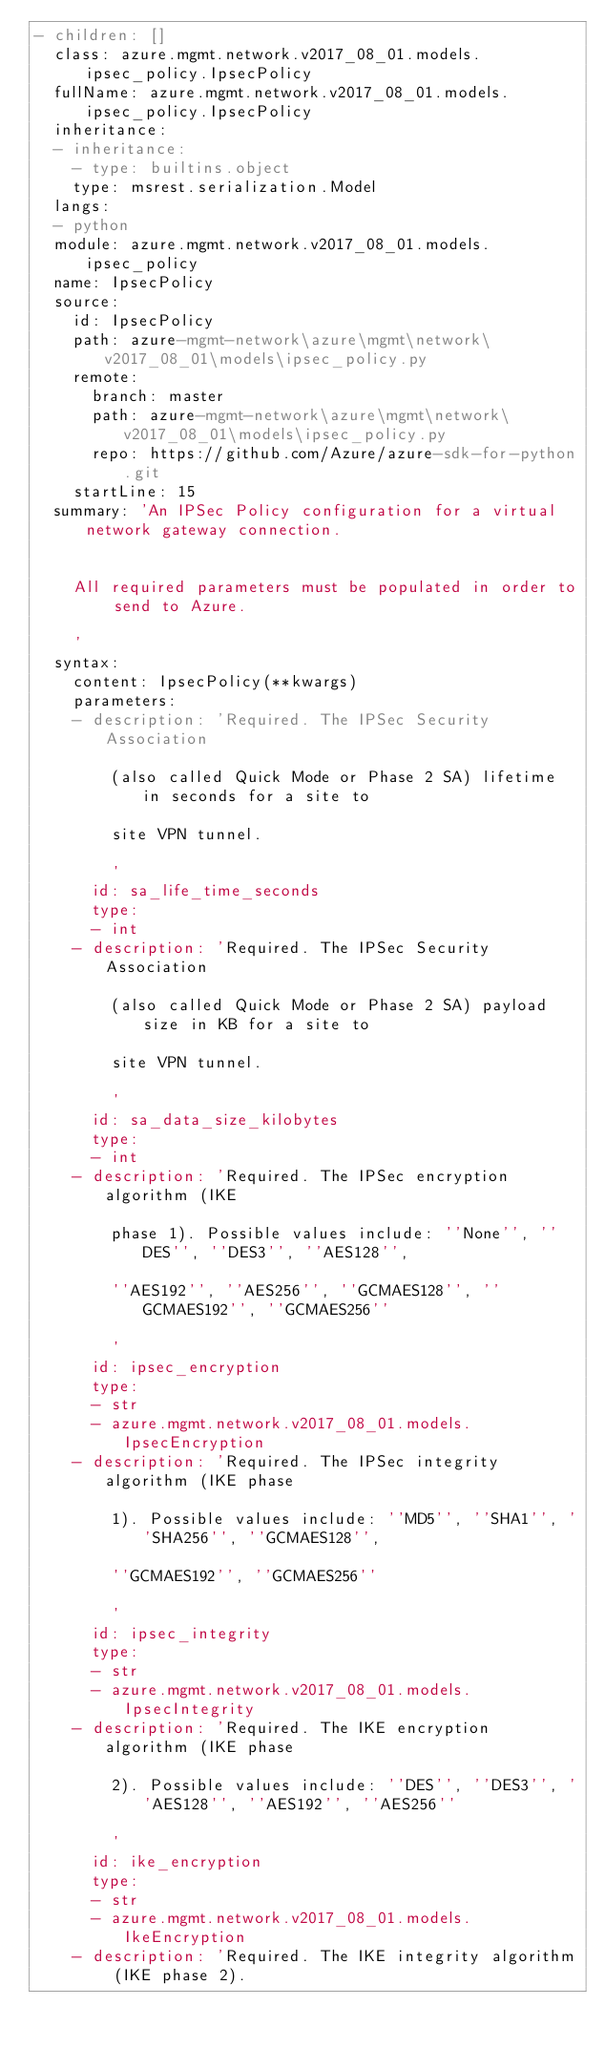Convert code to text. <code><loc_0><loc_0><loc_500><loc_500><_YAML_>- children: []
  class: azure.mgmt.network.v2017_08_01.models.ipsec_policy.IpsecPolicy
  fullName: azure.mgmt.network.v2017_08_01.models.ipsec_policy.IpsecPolicy
  inheritance:
  - inheritance:
    - type: builtins.object
    type: msrest.serialization.Model
  langs:
  - python
  module: azure.mgmt.network.v2017_08_01.models.ipsec_policy
  name: IpsecPolicy
  source:
    id: IpsecPolicy
    path: azure-mgmt-network\azure\mgmt\network\v2017_08_01\models\ipsec_policy.py
    remote:
      branch: master
      path: azure-mgmt-network\azure\mgmt\network\v2017_08_01\models\ipsec_policy.py
      repo: https://github.com/Azure/azure-sdk-for-python.git
    startLine: 15
  summary: 'An IPSec Policy configuration for a virtual network gateway connection.


    All required parameters must be populated in order to send to Azure.

    '
  syntax:
    content: IpsecPolicy(**kwargs)
    parameters:
    - description: 'Required. The IPSec Security Association

        (also called Quick Mode or Phase 2 SA) lifetime in seconds for a site to

        site VPN tunnel.

        '
      id: sa_life_time_seconds
      type:
      - int
    - description: 'Required. The IPSec Security Association

        (also called Quick Mode or Phase 2 SA) payload size in KB for a site to

        site VPN tunnel.

        '
      id: sa_data_size_kilobytes
      type:
      - int
    - description: 'Required. The IPSec encryption algorithm (IKE

        phase 1). Possible values include: ''None'', ''DES'', ''DES3'', ''AES128'',

        ''AES192'', ''AES256'', ''GCMAES128'', ''GCMAES192'', ''GCMAES256''

        '
      id: ipsec_encryption
      type:
      - str
      - azure.mgmt.network.v2017_08_01.models.IpsecEncryption
    - description: 'Required. The IPSec integrity algorithm (IKE phase

        1). Possible values include: ''MD5'', ''SHA1'', ''SHA256'', ''GCMAES128'',

        ''GCMAES192'', ''GCMAES256''

        '
      id: ipsec_integrity
      type:
      - str
      - azure.mgmt.network.v2017_08_01.models.IpsecIntegrity
    - description: 'Required. The IKE encryption algorithm (IKE phase

        2). Possible values include: ''DES'', ''DES3'', ''AES128'', ''AES192'', ''AES256''

        '
      id: ike_encryption
      type:
      - str
      - azure.mgmt.network.v2017_08_01.models.IkeEncryption
    - description: 'Required. The IKE integrity algorithm (IKE phase 2).
</code> 